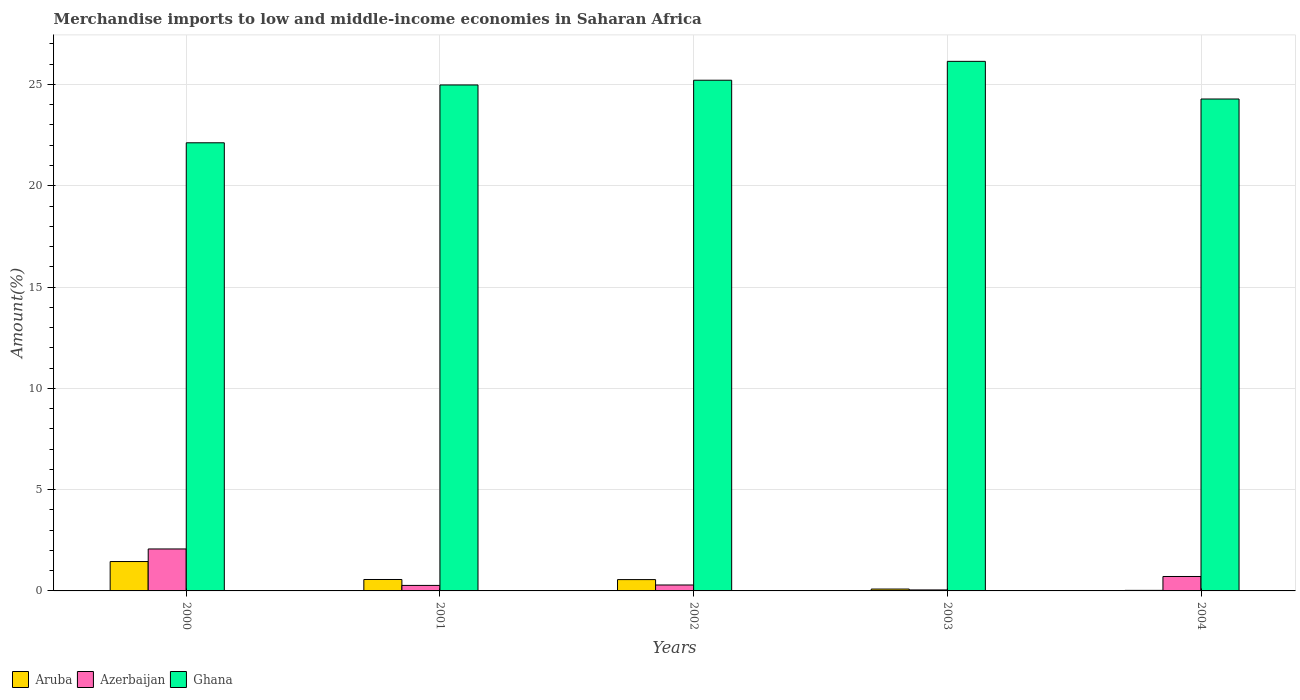How many different coloured bars are there?
Ensure brevity in your answer.  3. Are the number of bars on each tick of the X-axis equal?
Make the answer very short. Yes. What is the percentage of amount earned from merchandise imports in Aruba in 2000?
Give a very brief answer. 1.45. Across all years, what is the maximum percentage of amount earned from merchandise imports in Aruba?
Give a very brief answer. 1.45. Across all years, what is the minimum percentage of amount earned from merchandise imports in Azerbaijan?
Provide a succinct answer. 0.05. In which year was the percentage of amount earned from merchandise imports in Ghana maximum?
Offer a very short reply. 2003. In which year was the percentage of amount earned from merchandise imports in Ghana minimum?
Provide a short and direct response. 2000. What is the total percentage of amount earned from merchandise imports in Azerbaijan in the graph?
Make the answer very short. 3.4. What is the difference between the percentage of amount earned from merchandise imports in Ghana in 2003 and that in 2004?
Offer a terse response. 1.86. What is the difference between the percentage of amount earned from merchandise imports in Aruba in 2003 and the percentage of amount earned from merchandise imports in Ghana in 2002?
Offer a very short reply. -25.12. What is the average percentage of amount earned from merchandise imports in Azerbaijan per year?
Your answer should be very brief. 0.68. In the year 2001, what is the difference between the percentage of amount earned from merchandise imports in Azerbaijan and percentage of amount earned from merchandise imports in Ghana?
Keep it short and to the point. -24.7. What is the ratio of the percentage of amount earned from merchandise imports in Aruba in 2000 to that in 2002?
Your answer should be very brief. 2.59. What is the difference between the highest and the second highest percentage of amount earned from merchandise imports in Ghana?
Give a very brief answer. 0.93. What is the difference between the highest and the lowest percentage of amount earned from merchandise imports in Azerbaijan?
Provide a short and direct response. 2.02. In how many years, is the percentage of amount earned from merchandise imports in Ghana greater than the average percentage of amount earned from merchandise imports in Ghana taken over all years?
Make the answer very short. 3. Is the sum of the percentage of amount earned from merchandise imports in Aruba in 2000 and 2002 greater than the maximum percentage of amount earned from merchandise imports in Azerbaijan across all years?
Keep it short and to the point. No. What does the 2nd bar from the right in 2001 represents?
Your answer should be very brief. Azerbaijan. How many bars are there?
Your answer should be compact. 15. How many years are there in the graph?
Offer a terse response. 5. Are the values on the major ticks of Y-axis written in scientific E-notation?
Keep it short and to the point. No. Does the graph contain any zero values?
Your response must be concise. No. What is the title of the graph?
Your answer should be very brief. Merchandise imports to low and middle-income economies in Saharan Africa. Does "Grenada" appear as one of the legend labels in the graph?
Give a very brief answer. No. What is the label or title of the X-axis?
Give a very brief answer. Years. What is the label or title of the Y-axis?
Give a very brief answer. Amount(%). What is the Amount(%) in Aruba in 2000?
Offer a very short reply. 1.45. What is the Amount(%) of Azerbaijan in 2000?
Your answer should be compact. 2.07. What is the Amount(%) of Ghana in 2000?
Ensure brevity in your answer.  22.12. What is the Amount(%) of Aruba in 2001?
Keep it short and to the point. 0.56. What is the Amount(%) in Azerbaijan in 2001?
Your answer should be very brief. 0.27. What is the Amount(%) in Ghana in 2001?
Provide a succinct answer. 24.97. What is the Amount(%) of Aruba in 2002?
Offer a very short reply. 0.56. What is the Amount(%) in Azerbaijan in 2002?
Offer a very short reply. 0.29. What is the Amount(%) of Ghana in 2002?
Ensure brevity in your answer.  25.21. What is the Amount(%) of Aruba in 2003?
Your answer should be very brief. 0.09. What is the Amount(%) in Azerbaijan in 2003?
Your answer should be very brief. 0.05. What is the Amount(%) in Ghana in 2003?
Ensure brevity in your answer.  26.14. What is the Amount(%) in Aruba in 2004?
Offer a terse response. 0.03. What is the Amount(%) in Azerbaijan in 2004?
Make the answer very short. 0.71. What is the Amount(%) of Ghana in 2004?
Keep it short and to the point. 24.28. Across all years, what is the maximum Amount(%) of Aruba?
Your answer should be compact. 1.45. Across all years, what is the maximum Amount(%) in Azerbaijan?
Your answer should be very brief. 2.07. Across all years, what is the maximum Amount(%) of Ghana?
Provide a succinct answer. 26.14. Across all years, what is the minimum Amount(%) of Aruba?
Ensure brevity in your answer.  0.03. Across all years, what is the minimum Amount(%) of Azerbaijan?
Ensure brevity in your answer.  0.05. Across all years, what is the minimum Amount(%) of Ghana?
Your answer should be compact. 22.12. What is the total Amount(%) in Aruba in the graph?
Make the answer very short. 2.69. What is the total Amount(%) in Azerbaijan in the graph?
Keep it short and to the point. 3.4. What is the total Amount(%) of Ghana in the graph?
Make the answer very short. 122.73. What is the difference between the Amount(%) in Aruba in 2000 and that in 2001?
Provide a short and direct response. 0.89. What is the difference between the Amount(%) in Azerbaijan in 2000 and that in 2001?
Your answer should be compact. 1.8. What is the difference between the Amount(%) in Ghana in 2000 and that in 2001?
Your response must be concise. -2.85. What is the difference between the Amount(%) in Aruba in 2000 and that in 2002?
Offer a very short reply. 0.89. What is the difference between the Amount(%) of Azerbaijan in 2000 and that in 2002?
Give a very brief answer. 1.78. What is the difference between the Amount(%) in Ghana in 2000 and that in 2002?
Make the answer very short. -3.09. What is the difference between the Amount(%) in Aruba in 2000 and that in 2003?
Your response must be concise. 1.36. What is the difference between the Amount(%) in Azerbaijan in 2000 and that in 2003?
Provide a succinct answer. 2.02. What is the difference between the Amount(%) of Ghana in 2000 and that in 2003?
Your answer should be compact. -4.02. What is the difference between the Amount(%) in Aruba in 2000 and that in 2004?
Keep it short and to the point. 1.42. What is the difference between the Amount(%) in Azerbaijan in 2000 and that in 2004?
Ensure brevity in your answer.  1.36. What is the difference between the Amount(%) in Ghana in 2000 and that in 2004?
Your response must be concise. -2.16. What is the difference between the Amount(%) of Aruba in 2001 and that in 2002?
Make the answer very short. 0.01. What is the difference between the Amount(%) of Azerbaijan in 2001 and that in 2002?
Make the answer very short. -0.02. What is the difference between the Amount(%) of Ghana in 2001 and that in 2002?
Offer a very short reply. -0.23. What is the difference between the Amount(%) of Aruba in 2001 and that in 2003?
Give a very brief answer. 0.47. What is the difference between the Amount(%) of Azerbaijan in 2001 and that in 2003?
Your answer should be compact. 0.22. What is the difference between the Amount(%) of Ghana in 2001 and that in 2003?
Offer a terse response. -1.17. What is the difference between the Amount(%) in Aruba in 2001 and that in 2004?
Ensure brevity in your answer.  0.54. What is the difference between the Amount(%) of Azerbaijan in 2001 and that in 2004?
Offer a terse response. -0.44. What is the difference between the Amount(%) in Ghana in 2001 and that in 2004?
Keep it short and to the point. 0.69. What is the difference between the Amount(%) of Aruba in 2002 and that in 2003?
Provide a short and direct response. 0.47. What is the difference between the Amount(%) in Azerbaijan in 2002 and that in 2003?
Ensure brevity in your answer.  0.24. What is the difference between the Amount(%) of Ghana in 2002 and that in 2003?
Keep it short and to the point. -0.93. What is the difference between the Amount(%) in Aruba in 2002 and that in 2004?
Provide a succinct answer. 0.53. What is the difference between the Amount(%) in Azerbaijan in 2002 and that in 2004?
Offer a very short reply. -0.42. What is the difference between the Amount(%) of Ghana in 2002 and that in 2004?
Offer a very short reply. 0.93. What is the difference between the Amount(%) of Aruba in 2003 and that in 2004?
Offer a very short reply. 0.06. What is the difference between the Amount(%) of Azerbaijan in 2003 and that in 2004?
Provide a succinct answer. -0.66. What is the difference between the Amount(%) in Ghana in 2003 and that in 2004?
Give a very brief answer. 1.86. What is the difference between the Amount(%) in Aruba in 2000 and the Amount(%) in Azerbaijan in 2001?
Keep it short and to the point. 1.18. What is the difference between the Amount(%) of Aruba in 2000 and the Amount(%) of Ghana in 2001?
Offer a terse response. -23.52. What is the difference between the Amount(%) of Azerbaijan in 2000 and the Amount(%) of Ghana in 2001?
Give a very brief answer. -22.9. What is the difference between the Amount(%) of Aruba in 2000 and the Amount(%) of Azerbaijan in 2002?
Offer a terse response. 1.16. What is the difference between the Amount(%) of Aruba in 2000 and the Amount(%) of Ghana in 2002?
Give a very brief answer. -23.76. What is the difference between the Amount(%) of Azerbaijan in 2000 and the Amount(%) of Ghana in 2002?
Your answer should be very brief. -23.14. What is the difference between the Amount(%) in Aruba in 2000 and the Amount(%) in Azerbaijan in 2003?
Offer a very short reply. 1.4. What is the difference between the Amount(%) of Aruba in 2000 and the Amount(%) of Ghana in 2003?
Give a very brief answer. -24.69. What is the difference between the Amount(%) of Azerbaijan in 2000 and the Amount(%) of Ghana in 2003?
Ensure brevity in your answer.  -24.07. What is the difference between the Amount(%) in Aruba in 2000 and the Amount(%) in Azerbaijan in 2004?
Keep it short and to the point. 0.74. What is the difference between the Amount(%) of Aruba in 2000 and the Amount(%) of Ghana in 2004?
Make the answer very short. -22.83. What is the difference between the Amount(%) of Azerbaijan in 2000 and the Amount(%) of Ghana in 2004?
Provide a short and direct response. -22.21. What is the difference between the Amount(%) of Aruba in 2001 and the Amount(%) of Azerbaijan in 2002?
Provide a succinct answer. 0.27. What is the difference between the Amount(%) in Aruba in 2001 and the Amount(%) in Ghana in 2002?
Offer a very short reply. -24.64. What is the difference between the Amount(%) of Azerbaijan in 2001 and the Amount(%) of Ghana in 2002?
Your answer should be compact. -24.94. What is the difference between the Amount(%) in Aruba in 2001 and the Amount(%) in Azerbaijan in 2003?
Keep it short and to the point. 0.52. What is the difference between the Amount(%) in Aruba in 2001 and the Amount(%) in Ghana in 2003?
Your response must be concise. -25.58. What is the difference between the Amount(%) in Azerbaijan in 2001 and the Amount(%) in Ghana in 2003?
Your response must be concise. -25.87. What is the difference between the Amount(%) in Aruba in 2001 and the Amount(%) in Azerbaijan in 2004?
Provide a short and direct response. -0.15. What is the difference between the Amount(%) of Aruba in 2001 and the Amount(%) of Ghana in 2004?
Your answer should be very brief. -23.72. What is the difference between the Amount(%) of Azerbaijan in 2001 and the Amount(%) of Ghana in 2004?
Provide a succinct answer. -24.01. What is the difference between the Amount(%) in Aruba in 2002 and the Amount(%) in Azerbaijan in 2003?
Keep it short and to the point. 0.51. What is the difference between the Amount(%) in Aruba in 2002 and the Amount(%) in Ghana in 2003?
Provide a short and direct response. -25.58. What is the difference between the Amount(%) of Azerbaijan in 2002 and the Amount(%) of Ghana in 2003?
Provide a short and direct response. -25.85. What is the difference between the Amount(%) of Aruba in 2002 and the Amount(%) of Azerbaijan in 2004?
Ensure brevity in your answer.  -0.15. What is the difference between the Amount(%) in Aruba in 2002 and the Amount(%) in Ghana in 2004?
Ensure brevity in your answer.  -23.72. What is the difference between the Amount(%) of Azerbaijan in 2002 and the Amount(%) of Ghana in 2004?
Your answer should be very brief. -23.99. What is the difference between the Amount(%) in Aruba in 2003 and the Amount(%) in Azerbaijan in 2004?
Your answer should be compact. -0.62. What is the difference between the Amount(%) of Aruba in 2003 and the Amount(%) of Ghana in 2004?
Your response must be concise. -24.19. What is the difference between the Amount(%) in Azerbaijan in 2003 and the Amount(%) in Ghana in 2004?
Your answer should be very brief. -24.23. What is the average Amount(%) in Aruba per year?
Ensure brevity in your answer.  0.54. What is the average Amount(%) in Azerbaijan per year?
Ensure brevity in your answer.  0.68. What is the average Amount(%) in Ghana per year?
Give a very brief answer. 24.55. In the year 2000, what is the difference between the Amount(%) of Aruba and Amount(%) of Azerbaijan?
Provide a succinct answer. -0.62. In the year 2000, what is the difference between the Amount(%) of Aruba and Amount(%) of Ghana?
Keep it short and to the point. -20.67. In the year 2000, what is the difference between the Amount(%) in Azerbaijan and Amount(%) in Ghana?
Your response must be concise. -20.05. In the year 2001, what is the difference between the Amount(%) in Aruba and Amount(%) in Azerbaijan?
Provide a succinct answer. 0.29. In the year 2001, what is the difference between the Amount(%) of Aruba and Amount(%) of Ghana?
Your answer should be compact. -24.41. In the year 2001, what is the difference between the Amount(%) of Azerbaijan and Amount(%) of Ghana?
Your answer should be very brief. -24.7. In the year 2002, what is the difference between the Amount(%) in Aruba and Amount(%) in Azerbaijan?
Your answer should be very brief. 0.27. In the year 2002, what is the difference between the Amount(%) of Aruba and Amount(%) of Ghana?
Provide a short and direct response. -24.65. In the year 2002, what is the difference between the Amount(%) of Azerbaijan and Amount(%) of Ghana?
Provide a succinct answer. -24.92. In the year 2003, what is the difference between the Amount(%) in Aruba and Amount(%) in Azerbaijan?
Offer a terse response. 0.04. In the year 2003, what is the difference between the Amount(%) of Aruba and Amount(%) of Ghana?
Your answer should be compact. -26.05. In the year 2003, what is the difference between the Amount(%) in Azerbaijan and Amount(%) in Ghana?
Offer a terse response. -26.09. In the year 2004, what is the difference between the Amount(%) of Aruba and Amount(%) of Azerbaijan?
Your answer should be very brief. -0.68. In the year 2004, what is the difference between the Amount(%) in Aruba and Amount(%) in Ghana?
Give a very brief answer. -24.25. In the year 2004, what is the difference between the Amount(%) in Azerbaijan and Amount(%) in Ghana?
Provide a succinct answer. -23.57. What is the ratio of the Amount(%) in Aruba in 2000 to that in 2001?
Offer a very short reply. 2.57. What is the ratio of the Amount(%) of Azerbaijan in 2000 to that in 2001?
Provide a short and direct response. 7.62. What is the ratio of the Amount(%) in Ghana in 2000 to that in 2001?
Offer a very short reply. 0.89. What is the ratio of the Amount(%) of Aruba in 2000 to that in 2002?
Your response must be concise. 2.59. What is the ratio of the Amount(%) of Azerbaijan in 2000 to that in 2002?
Your answer should be very brief. 7.08. What is the ratio of the Amount(%) of Ghana in 2000 to that in 2002?
Provide a short and direct response. 0.88. What is the ratio of the Amount(%) in Aruba in 2000 to that in 2003?
Make the answer very short. 15.74. What is the ratio of the Amount(%) in Azerbaijan in 2000 to that in 2003?
Give a very brief answer. 42.44. What is the ratio of the Amount(%) of Ghana in 2000 to that in 2003?
Provide a short and direct response. 0.85. What is the ratio of the Amount(%) in Aruba in 2000 to that in 2004?
Provide a succinct answer. 52.43. What is the ratio of the Amount(%) in Azerbaijan in 2000 to that in 2004?
Provide a succinct answer. 2.91. What is the ratio of the Amount(%) in Ghana in 2000 to that in 2004?
Keep it short and to the point. 0.91. What is the ratio of the Amount(%) of Azerbaijan in 2001 to that in 2002?
Provide a short and direct response. 0.93. What is the ratio of the Amount(%) in Aruba in 2001 to that in 2003?
Make the answer very short. 6.12. What is the ratio of the Amount(%) of Azerbaijan in 2001 to that in 2003?
Your response must be concise. 5.57. What is the ratio of the Amount(%) in Ghana in 2001 to that in 2003?
Offer a very short reply. 0.96. What is the ratio of the Amount(%) of Aruba in 2001 to that in 2004?
Provide a short and direct response. 20.39. What is the ratio of the Amount(%) of Azerbaijan in 2001 to that in 2004?
Make the answer very short. 0.38. What is the ratio of the Amount(%) in Ghana in 2001 to that in 2004?
Your answer should be very brief. 1.03. What is the ratio of the Amount(%) in Aruba in 2002 to that in 2003?
Give a very brief answer. 6.07. What is the ratio of the Amount(%) in Azerbaijan in 2002 to that in 2003?
Make the answer very short. 6. What is the ratio of the Amount(%) in Ghana in 2002 to that in 2003?
Offer a terse response. 0.96. What is the ratio of the Amount(%) of Aruba in 2002 to that in 2004?
Provide a succinct answer. 20.21. What is the ratio of the Amount(%) of Azerbaijan in 2002 to that in 2004?
Provide a short and direct response. 0.41. What is the ratio of the Amount(%) of Ghana in 2002 to that in 2004?
Keep it short and to the point. 1.04. What is the ratio of the Amount(%) in Aruba in 2003 to that in 2004?
Your answer should be very brief. 3.33. What is the ratio of the Amount(%) in Azerbaijan in 2003 to that in 2004?
Provide a short and direct response. 0.07. What is the ratio of the Amount(%) in Ghana in 2003 to that in 2004?
Give a very brief answer. 1.08. What is the difference between the highest and the second highest Amount(%) in Aruba?
Your answer should be compact. 0.89. What is the difference between the highest and the second highest Amount(%) in Azerbaijan?
Keep it short and to the point. 1.36. What is the difference between the highest and the second highest Amount(%) in Ghana?
Keep it short and to the point. 0.93. What is the difference between the highest and the lowest Amount(%) of Aruba?
Your answer should be very brief. 1.42. What is the difference between the highest and the lowest Amount(%) in Azerbaijan?
Keep it short and to the point. 2.02. What is the difference between the highest and the lowest Amount(%) of Ghana?
Offer a very short reply. 4.02. 